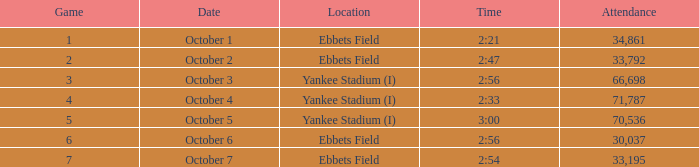Location of ebbets field, and a Time of 2:56, and a Game larger than 6 has what sum of attendance? None. 